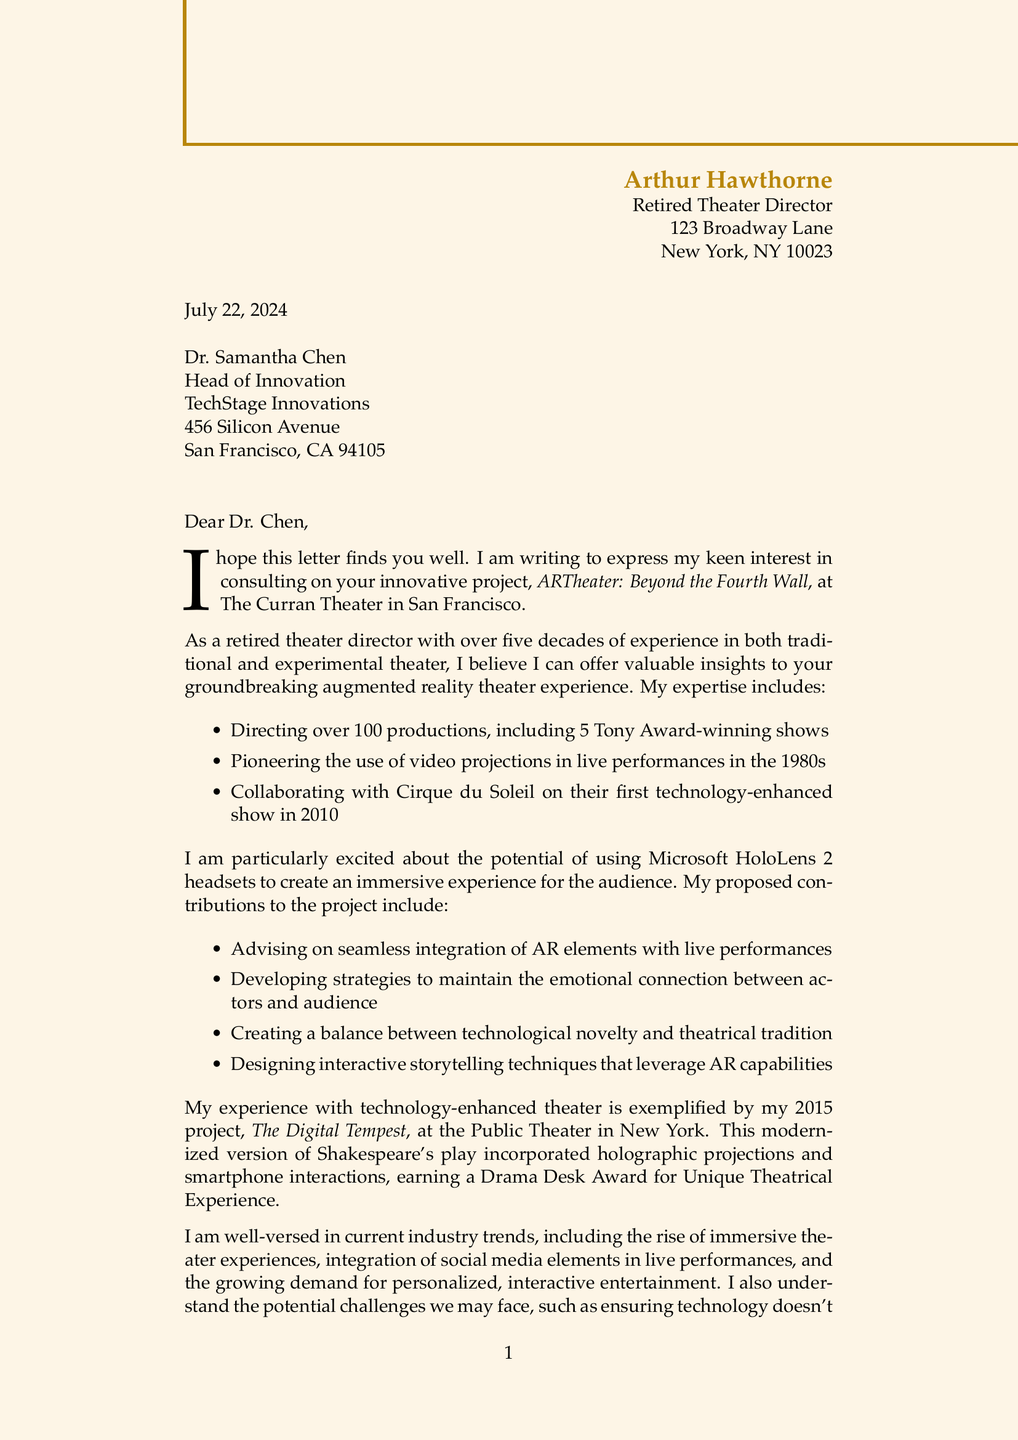What is the name of the project? The project name is specified in the document under project details.
Answer: ARTheater: Beyond the Fourth Wall Who is the sender of the letter? The sender's name and title are provided at the beginning of the document.
Answer: Arthur Hawthorne What technology is proposed for audience members? The specific technology mentioned in the project details refers to the equipment used for the audience.
Answer: Microsoft HoloLens 2 headsets What year did the project 'The Digital Tempest' take place? The year is mentioned alongside the project description in the letter.
Answer: 2015 What is one potential challenge mentioned in the document? The challenges are outlined in a specific section and may require the reader to recall details.
Answer: Ensuring technology doesn't overshadow the human element of theater What accolade did 'The Digital Tempest' project achieve? The accolades received by the project are highlighted in the relevant experience section.
Answer: Drama Desk Award for Unique Theatrical Experience What venue is associated with the ARTheater project? The venue is mentioned in the project details section of the letter.
Answer: The Curran Theater, San Francisco What is the availability of the sender for consultations? The sender's availability is provided in the closing remarks section of the document.
Answer: Starting next month What is the sender's vision for the project? The vision is stated in the closing remarks, reflecting the sender's aspirations for the project.
Answer: Bridging the gap between traditional theater and cutting-edge technology to create unforgettable experiences 